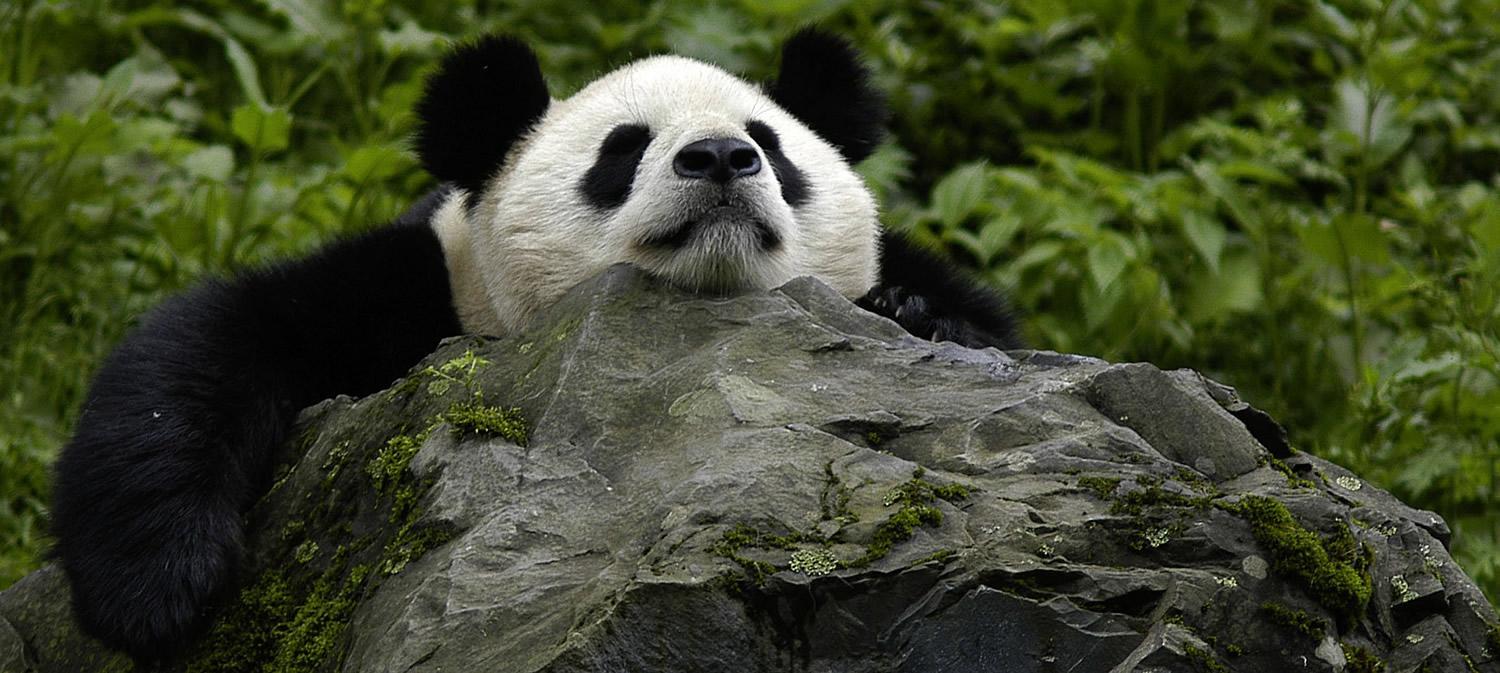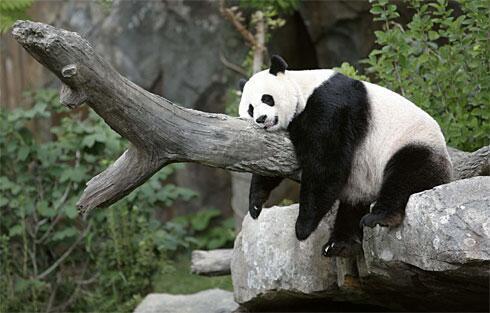The first image is the image on the left, the second image is the image on the right. Given the left and right images, does the statement "Two pandas are laying forward." hold true? Answer yes or no. Yes. 